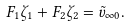Convert formula to latex. <formula><loc_0><loc_0><loc_500><loc_500>F _ { 1 } \zeta _ { 1 } + F _ { 2 } \zeta _ { 2 } = \tilde { v } _ { \infty 0 } .</formula> 